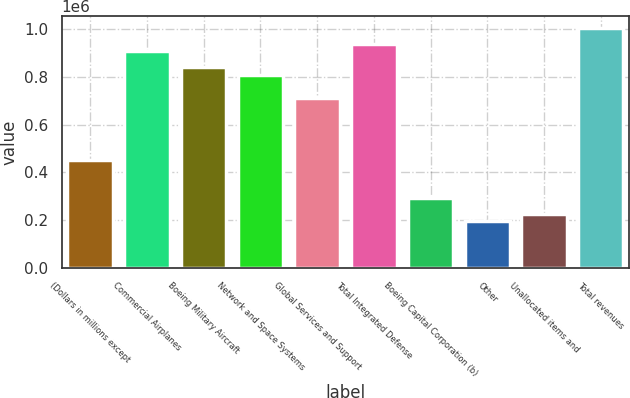Convert chart to OTSL. <chart><loc_0><loc_0><loc_500><loc_500><bar_chart><fcel>(Dollars in millions except<fcel>Commercial Airplanes<fcel>Boeing Military Aircraft<fcel>Network and Space Systems<fcel>Global Services and Support<fcel>Total Integrated Defense<fcel>Boeing Capital Corporation (b)<fcel>Other<fcel>Unallocated items and<fcel>Total revenues<nl><fcel>453403<fcel>906805<fcel>842033<fcel>809648<fcel>712490<fcel>939191<fcel>291474<fcel>194317<fcel>226702<fcel>1.00396e+06<nl></chart> 